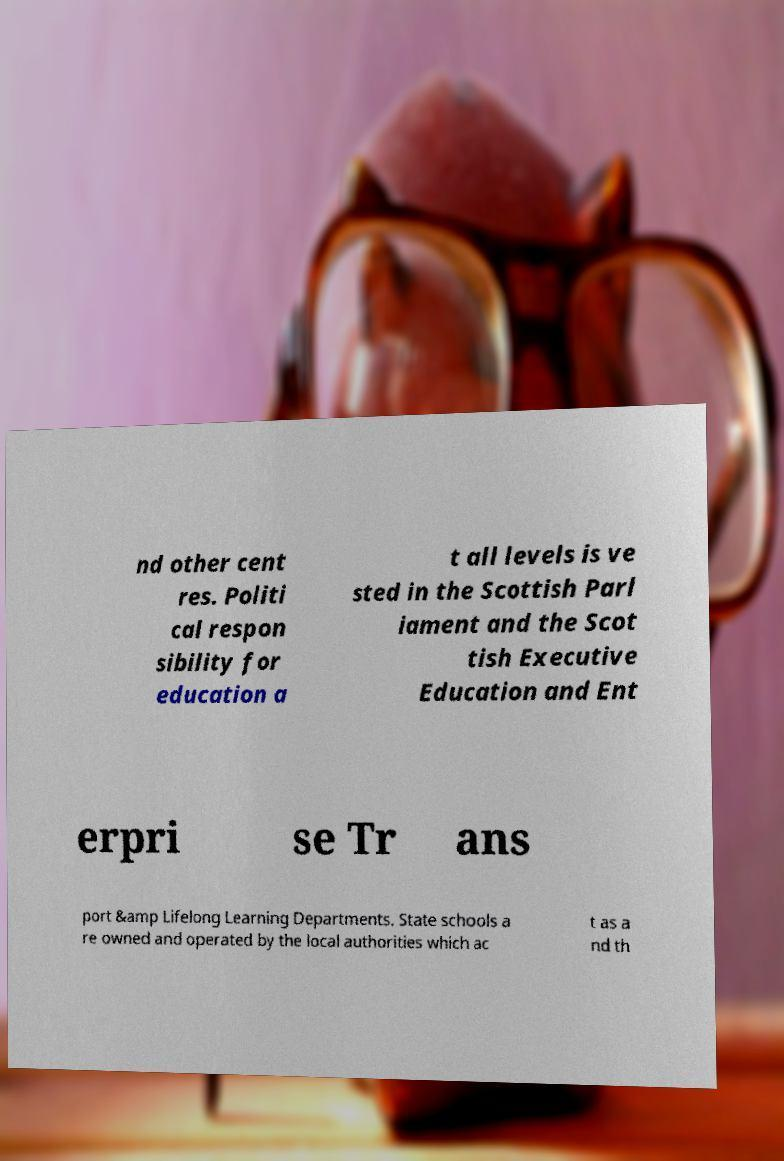I need the written content from this picture converted into text. Can you do that? nd other cent res. Politi cal respon sibility for education a t all levels is ve sted in the Scottish Parl iament and the Scot tish Executive Education and Ent erpri se Tr ans port &amp Lifelong Learning Departments. State schools a re owned and operated by the local authorities which ac t as a nd th 